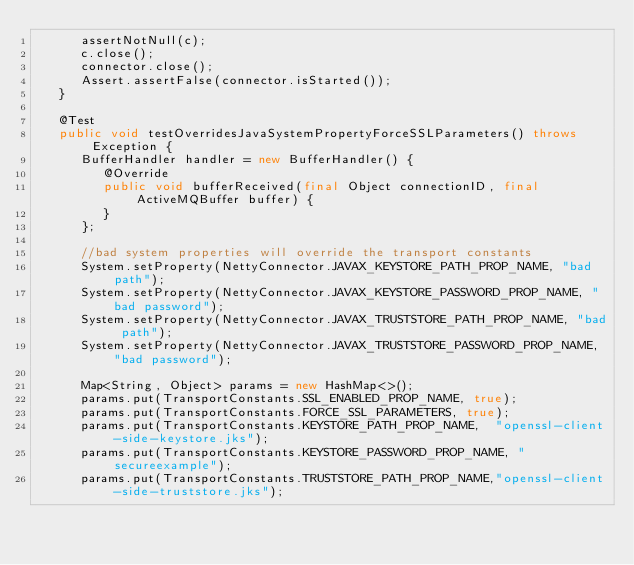Convert code to text. <code><loc_0><loc_0><loc_500><loc_500><_Java_>      assertNotNull(c);
      c.close();
      connector.close();
      Assert.assertFalse(connector.isStarted());
   }

   @Test
   public void testOverridesJavaSystemPropertyForceSSLParameters() throws Exception {
      BufferHandler handler = new BufferHandler() {
         @Override
         public void bufferReceived(final Object connectionID, final ActiveMQBuffer buffer) {
         }
      };

      //bad system properties will override the transport constants
      System.setProperty(NettyConnector.JAVAX_KEYSTORE_PATH_PROP_NAME, "bad path");
      System.setProperty(NettyConnector.JAVAX_KEYSTORE_PASSWORD_PROP_NAME, "bad password");
      System.setProperty(NettyConnector.JAVAX_TRUSTSTORE_PATH_PROP_NAME, "bad path");
      System.setProperty(NettyConnector.JAVAX_TRUSTSTORE_PASSWORD_PROP_NAME, "bad password");

      Map<String, Object> params = new HashMap<>();
      params.put(TransportConstants.SSL_ENABLED_PROP_NAME, true);
      params.put(TransportConstants.FORCE_SSL_PARAMETERS, true);
      params.put(TransportConstants.KEYSTORE_PATH_PROP_NAME,  "openssl-client-side-keystore.jks");
      params.put(TransportConstants.KEYSTORE_PASSWORD_PROP_NAME, "secureexample");
      params.put(TransportConstants.TRUSTSTORE_PATH_PROP_NAME,"openssl-client-side-truststore.jks");</code> 